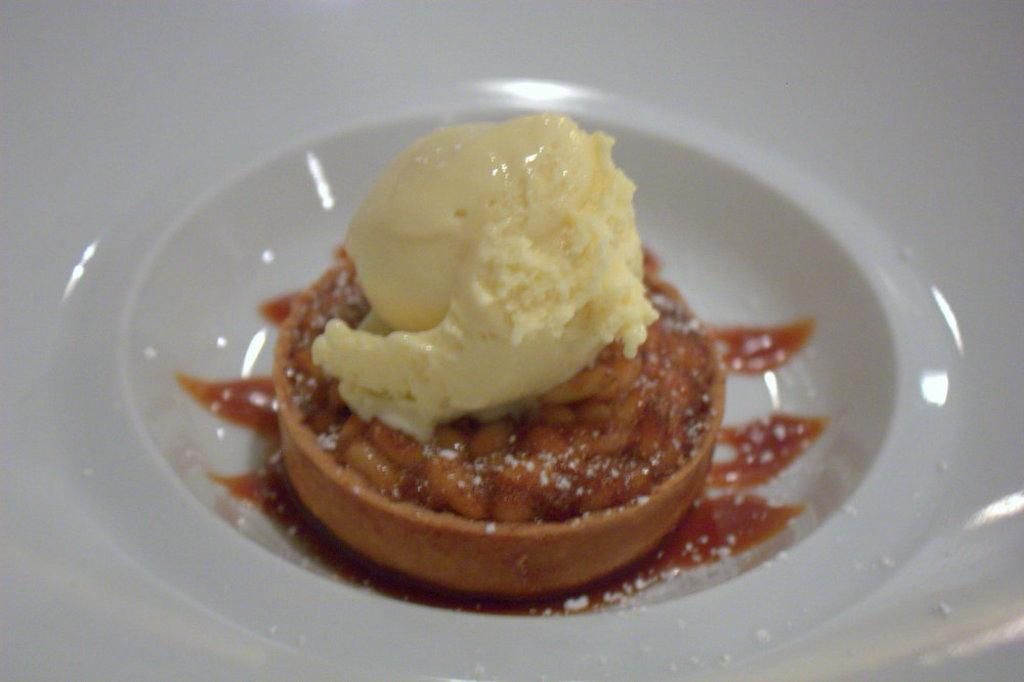What type of sweet is in the image? There is a sweet in the image. What flavor of ice cream is in the sweet? The sweet has mango ice cream. What color is the bowl in which the sweet is placed? The bowl is white-colored. What government policy is being discussed in the image? There is no discussion or reference to any government policy in the image; it features a sweet with mango ice cream in a white-colored bowl. What action is being performed by the sweet in the image? The sweet is not performing any action in the image; it is stationary in the bowl. 